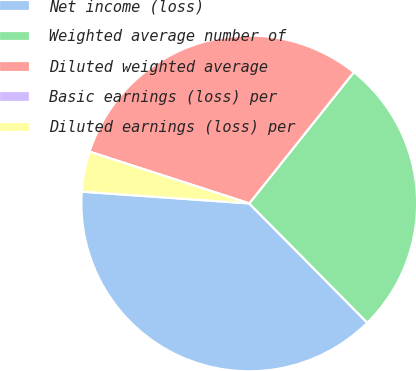<chart> <loc_0><loc_0><loc_500><loc_500><pie_chart><fcel>Net income (loss)<fcel>Weighted average number of<fcel>Diluted weighted average<fcel>Basic earnings (loss) per<fcel>Diluted earnings (loss) per<nl><fcel>38.54%<fcel>26.87%<fcel>30.73%<fcel>0.0%<fcel>3.86%<nl></chart> 